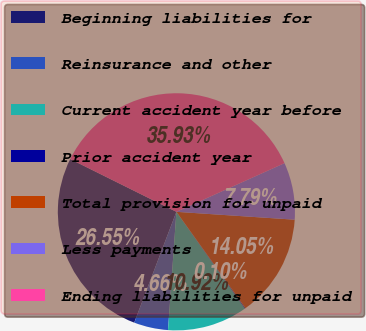Convert chart to OTSL. <chart><loc_0><loc_0><loc_500><loc_500><pie_chart><fcel>Beginning liabilities for<fcel>Reinsurance and other<fcel>Current accident year before<fcel>Prior accident year<fcel>Total provision for unpaid<fcel>Less payments<fcel>Ending liabilities for unpaid<nl><fcel>26.55%<fcel>4.66%<fcel>10.92%<fcel>0.1%<fcel>14.05%<fcel>7.79%<fcel>35.93%<nl></chart> 